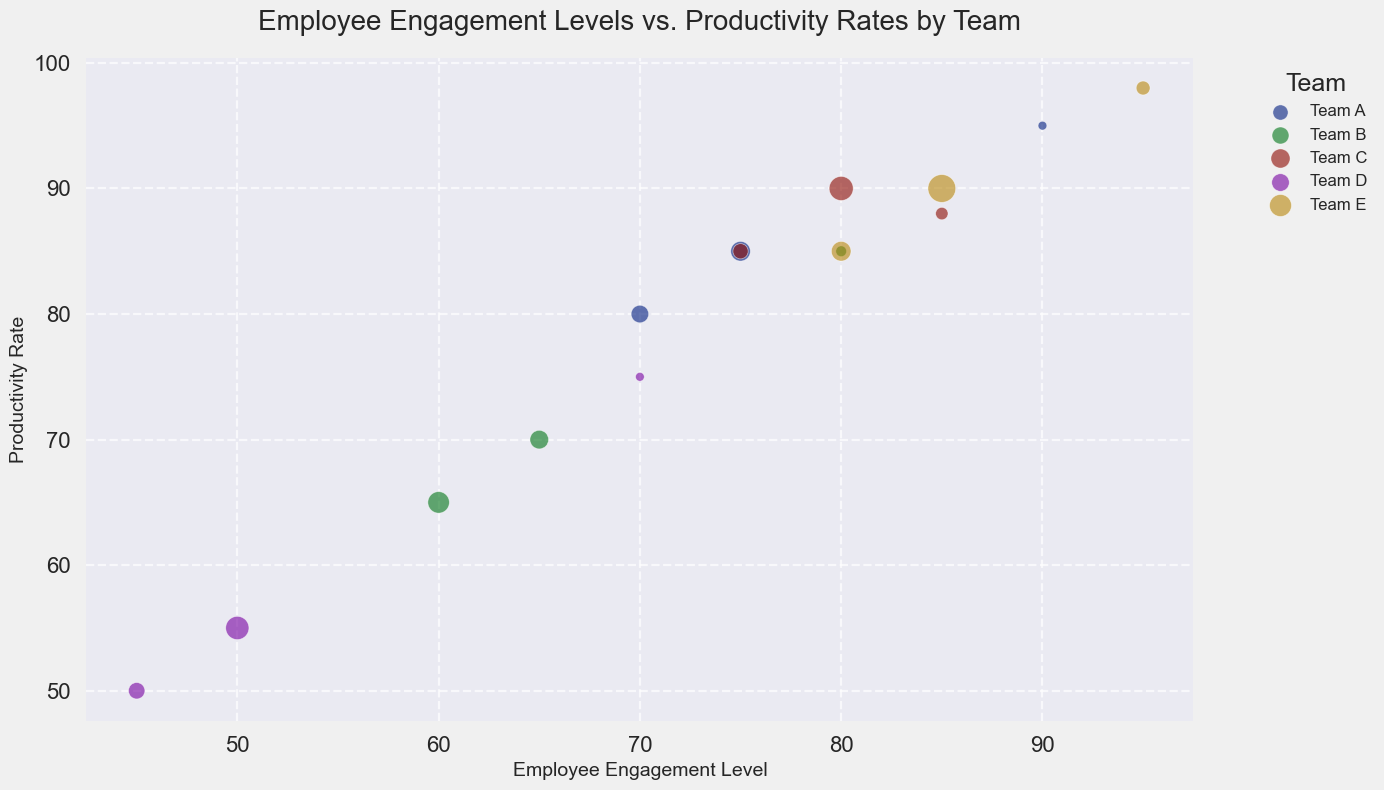Which team has the highest productivity rate? Team E has the highest productivity rate. This information can be visually identified from the bubble locations on the vertical (y) axis, where Team E's Project Manager has a productivity rate of 98.
Answer: Team E Which role in Team D has the lowest employee engagement level? The lowest employee engagement level in Team D is for QA Engineers, which can be seen at 45 on the horizontal (x) axis.
Answer: QA Engineer Compare the productivity rates of Software Engineers in Team C and Team D. Which is higher? Team C's Software Engineers have a productivity rate of 90, while Team D's have a productivity rate of 55. Therefore, Team C's productivity rate is higher.
Answer: Team C's Software Engineers What is the sum of the productivity rates for all Project Managers? Each team's Project Manager productivity rates are summed as follows: Team A (95) + Team B (85) + Team C (88) + Team D (75) + Team E (98). Therefore, 95 + 85 + 88 + 75 + 98 = 441.
Answer: 441 Which team has the largest bubble size for Software Engineers, indicating the highest number of employees? The largest bubble size for Software Engineers can be visually identified. Team E shows the largest bubble, representing 20 employees.
Answer: Team E What is the visual relationship between the number of employees and the bubble size? Larger bubbles represent teams with more employees and smaller bubbles represent teams with fewer employees. This is visually consistent across the chart.
Answer: Larger bubbles indicate more employees Is there any team whose Project Manager’s productivity rate is less than their Software Engineers’ engagement level? Examining the bubble positions, for all teams, Project Managers have higher productivity rates than their Software Engineers' engagement levels. There is no instance where a Project Manager's productivity rate is less.
Answer: No Compare the employee engagement levels of QA Engineers across all teams. Which team has the highest engagement level? The highest engagement level for QA Engineers can be found at Team E, with an engagement level of 80. This is visually identified on the horizontal (x) axis.
Answer: Team E 